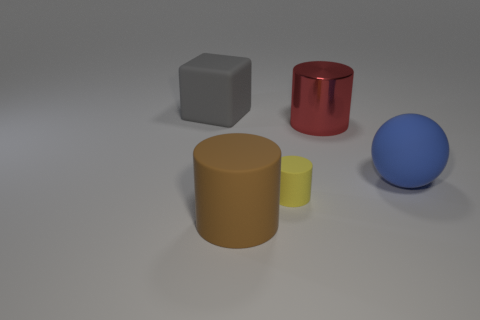Subtract all rubber cylinders. How many cylinders are left? 1 Add 3 big purple objects. How many objects exist? 8 Subtract 1 cylinders. How many cylinders are left? 2 Subtract all cylinders. How many objects are left? 2 Subtract all gray blocks. Subtract all big objects. How many objects are left? 0 Add 2 big balls. How many big balls are left? 3 Add 1 large rubber things. How many large rubber things exist? 4 Subtract 0 cyan cylinders. How many objects are left? 5 